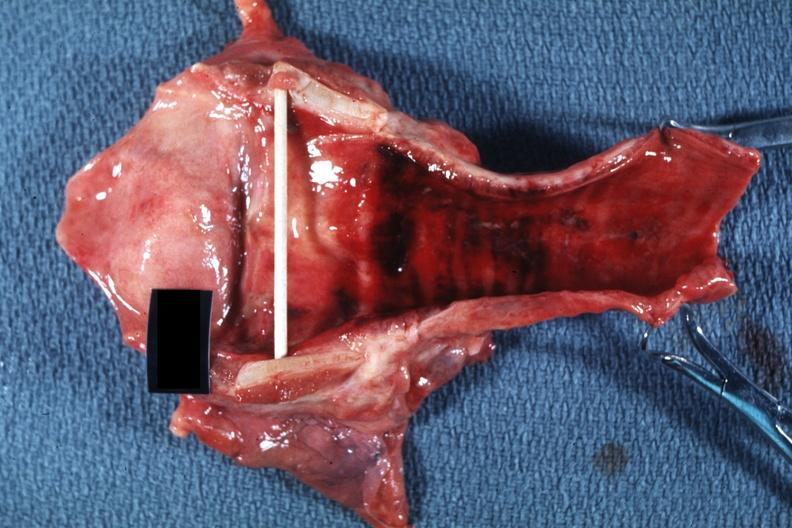does this image show good example probably due to intubation?
Answer the question using a single word or phrase. Yes 